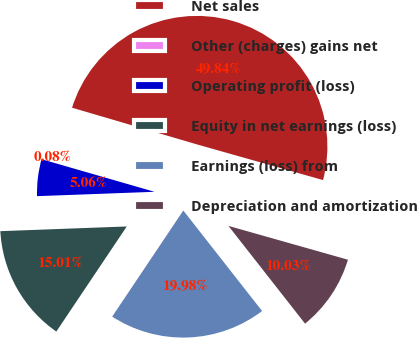<chart> <loc_0><loc_0><loc_500><loc_500><pie_chart><fcel>Net sales<fcel>Other (charges) gains net<fcel>Operating profit (loss)<fcel>Equity in net earnings (loss)<fcel>Earnings (loss) from<fcel>Depreciation and amortization<nl><fcel>49.84%<fcel>0.08%<fcel>5.06%<fcel>15.01%<fcel>19.98%<fcel>10.03%<nl></chart> 